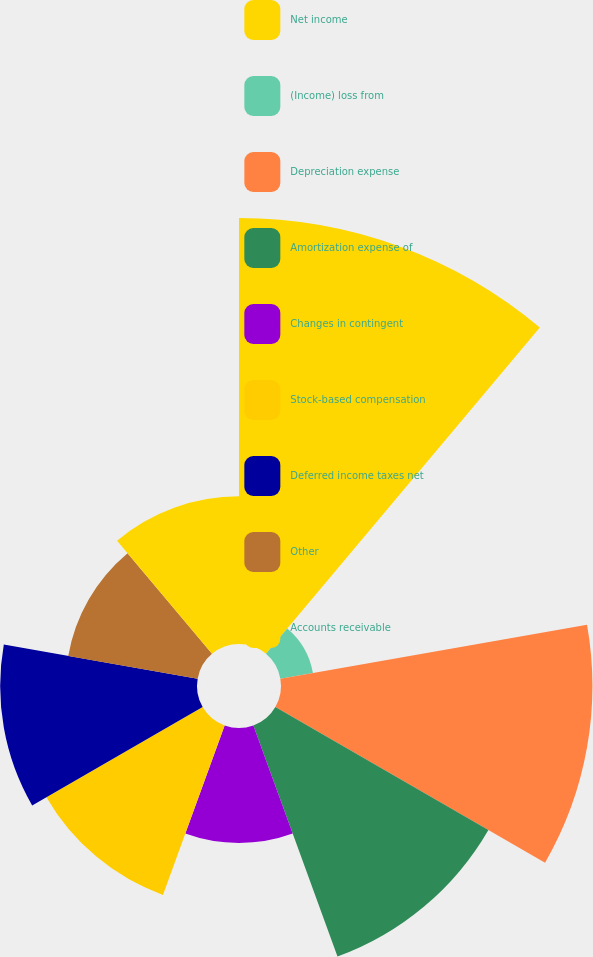<chart> <loc_0><loc_0><loc_500><loc_500><pie_chart><fcel>Net income<fcel>(Income) loss from<fcel>Depreciation expense<fcel>Amortization expense of<fcel>Changes in contingent<fcel>Stock-based compensation<fcel>Deferred income taxes net<fcel>Other<fcel>Accounts receivable<nl><fcel>23.83%<fcel>1.85%<fcel>17.42%<fcel>13.76%<fcel>6.43%<fcel>10.09%<fcel>11.01%<fcel>7.35%<fcel>8.26%<nl></chart> 